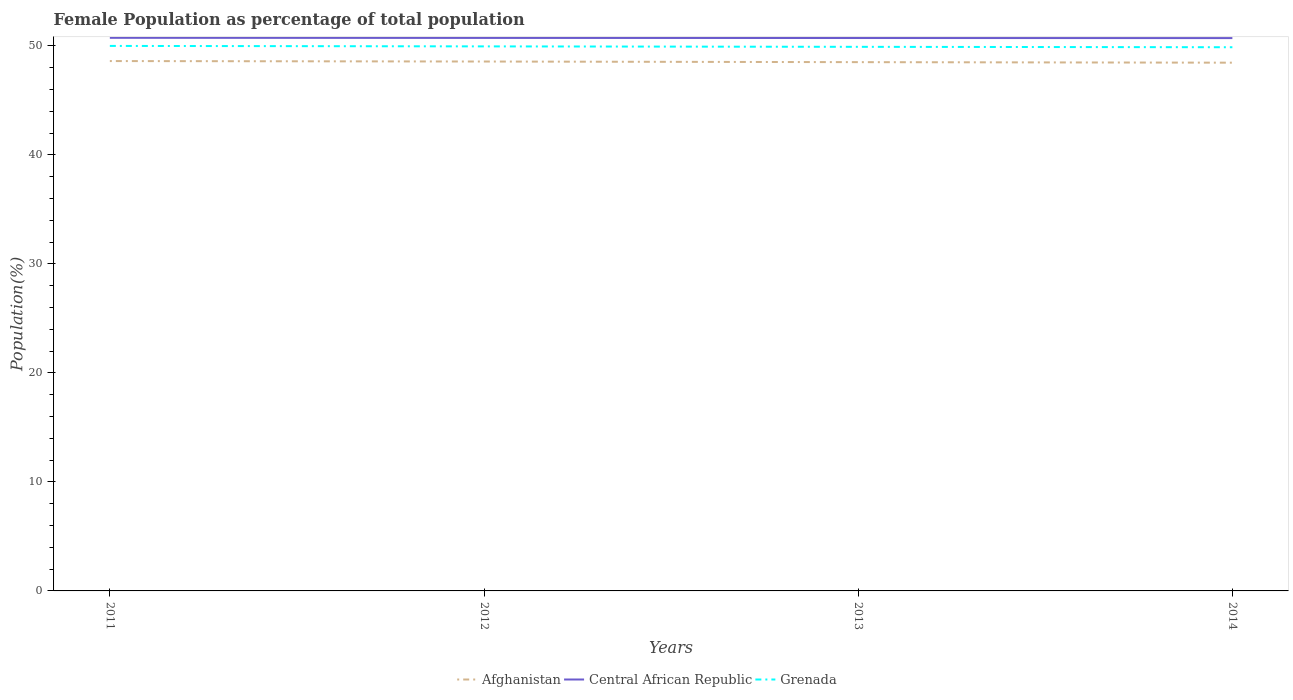How many different coloured lines are there?
Your response must be concise. 3. Does the line corresponding to Grenada intersect with the line corresponding to Afghanistan?
Provide a succinct answer. No. Is the number of lines equal to the number of legend labels?
Offer a very short reply. Yes. Across all years, what is the maximum female population in in Grenada?
Your answer should be compact. 49.87. In which year was the female population in in Central African Republic maximum?
Your answer should be very brief. 2014. What is the total female population in in Central African Republic in the graph?
Provide a short and direct response. 0.02. What is the difference between the highest and the second highest female population in in Central African Republic?
Offer a very short reply. 0.03. What is the difference between the highest and the lowest female population in in Afghanistan?
Offer a very short reply. 2. Does the graph contain any zero values?
Ensure brevity in your answer.  No. What is the title of the graph?
Offer a terse response. Female Population as percentage of total population. What is the label or title of the Y-axis?
Your answer should be very brief. Population(%). What is the Population(%) of Afghanistan in 2011?
Keep it short and to the point. 48.61. What is the Population(%) of Central African Republic in 2011?
Ensure brevity in your answer.  50.74. What is the Population(%) in Grenada in 2011?
Provide a succinct answer. 50. What is the Population(%) of Afghanistan in 2012?
Keep it short and to the point. 48.56. What is the Population(%) of Central African Republic in 2012?
Keep it short and to the point. 50.73. What is the Population(%) of Grenada in 2012?
Ensure brevity in your answer.  49.95. What is the Population(%) in Afghanistan in 2013?
Your answer should be compact. 48.51. What is the Population(%) in Central African Republic in 2013?
Ensure brevity in your answer.  50.72. What is the Population(%) in Grenada in 2013?
Your response must be concise. 49.91. What is the Population(%) of Afghanistan in 2014?
Provide a succinct answer. 48.46. What is the Population(%) in Central African Republic in 2014?
Offer a terse response. 50.71. What is the Population(%) of Grenada in 2014?
Your answer should be compact. 49.87. Across all years, what is the maximum Population(%) of Afghanistan?
Your answer should be very brief. 48.61. Across all years, what is the maximum Population(%) of Central African Republic?
Give a very brief answer. 50.74. Across all years, what is the maximum Population(%) in Grenada?
Your response must be concise. 50. Across all years, what is the minimum Population(%) in Afghanistan?
Provide a short and direct response. 48.46. Across all years, what is the minimum Population(%) of Central African Republic?
Make the answer very short. 50.71. Across all years, what is the minimum Population(%) in Grenada?
Keep it short and to the point. 49.87. What is the total Population(%) of Afghanistan in the graph?
Give a very brief answer. 194.14. What is the total Population(%) in Central African Republic in the graph?
Your response must be concise. 202.9. What is the total Population(%) in Grenada in the graph?
Offer a terse response. 199.73. What is the difference between the Population(%) of Afghanistan in 2011 and that in 2012?
Keep it short and to the point. 0.04. What is the difference between the Population(%) in Central African Republic in 2011 and that in 2012?
Your answer should be compact. 0.01. What is the difference between the Population(%) of Grenada in 2011 and that in 2012?
Keep it short and to the point. 0.04. What is the difference between the Population(%) of Afghanistan in 2011 and that in 2013?
Provide a short and direct response. 0.1. What is the difference between the Population(%) in Central African Republic in 2011 and that in 2013?
Provide a short and direct response. 0.02. What is the difference between the Population(%) in Grenada in 2011 and that in 2013?
Make the answer very short. 0.08. What is the difference between the Population(%) in Afghanistan in 2011 and that in 2014?
Your answer should be compact. 0.15. What is the difference between the Population(%) in Central African Republic in 2011 and that in 2014?
Offer a very short reply. 0.03. What is the difference between the Population(%) of Grenada in 2011 and that in 2014?
Ensure brevity in your answer.  0.12. What is the difference between the Population(%) of Afghanistan in 2012 and that in 2013?
Provide a short and direct response. 0.06. What is the difference between the Population(%) of Central African Republic in 2012 and that in 2013?
Offer a terse response. 0.01. What is the difference between the Population(%) in Grenada in 2012 and that in 2013?
Ensure brevity in your answer.  0.04. What is the difference between the Population(%) in Afghanistan in 2012 and that in 2014?
Make the answer very short. 0.11. What is the difference between the Population(%) of Central African Republic in 2012 and that in 2014?
Provide a short and direct response. 0.02. What is the difference between the Population(%) in Grenada in 2012 and that in 2014?
Offer a terse response. 0.08. What is the difference between the Population(%) in Afghanistan in 2013 and that in 2014?
Provide a short and direct response. 0.05. What is the difference between the Population(%) of Central African Republic in 2013 and that in 2014?
Give a very brief answer. 0.01. What is the difference between the Population(%) of Grenada in 2013 and that in 2014?
Ensure brevity in your answer.  0.04. What is the difference between the Population(%) of Afghanistan in 2011 and the Population(%) of Central African Republic in 2012?
Your answer should be very brief. -2.12. What is the difference between the Population(%) in Afghanistan in 2011 and the Population(%) in Grenada in 2012?
Your answer should be very brief. -1.35. What is the difference between the Population(%) in Central African Republic in 2011 and the Population(%) in Grenada in 2012?
Provide a succinct answer. 0.79. What is the difference between the Population(%) in Afghanistan in 2011 and the Population(%) in Central African Republic in 2013?
Offer a very short reply. -2.11. What is the difference between the Population(%) in Afghanistan in 2011 and the Population(%) in Grenada in 2013?
Your response must be concise. -1.31. What is the difference between the Population(%) of Central African Republic in 2011 and the Population(%) of Grenada in 2013?
Provide a succinct answer. 0.83. What is the difference between the Population(%) in Afghanistan in 2011 and the Population(%) in Central African Republic in 2014?
Give a very brief answer. -2.11. What is the difference between the Population(%) in Afghanistan in 2011 and the Population(%) in Grenada in 2014?
Give a very brief answer. -1.27. What is the difference between the Population(%) in Central African Republic in 2011 and the Population(%) in Grenada in 2014?
Offer a very short reply. 0.86. What is the difference between the Population(%) of Afghanistan in 2012 and the Population(%) of Central African Republic in 2013?
Give a very brief answer. -2.16. What is the difference between the Population(%) in Afghanistan in 2012 and the Population(%) in Grenada in 2013?
Give a very brief answer. -1.35. What is the difference between the Population(%) in Central African Republic in 2012 and the Population(%) in Grenada in 2013?
Provide a short and direct response. 0.82. What is the difference between the Population(%) in Afghanistan in 2012 and the Population(%) in Central African Republic in 2014?
Ensure brevity in your answer.  -2.15. What is the difference between the Population(%) in Afghanistan in 2012 and the Population(%) in Grenada in 2014?
Provide a short and direct response. -1.31. What is the difference between the Population(%) of Central African Republic in 2012 and the Population(%) of Grenada in 2014?
Offer a terse response. 0.85. What is the difference between the Population(%) in Afghanistan in 2013 and the Population(%) in Central African Republic in 2014?
Offer a terse response. -2.21. What is the difference between the Population(%) in Afghanistan in 2013 and the Population(%) in Grenada in 2014?
Offer a very short reply. -1.37. What is the difference between the Population(%) of Central African Republic in 2013 and the Population(%) of Grenada in 2014?
Offer a very short reply. 0.85. What is the average Population(%) of Afghanistan per year?
Keep it short and to the point. 48.53. What is the average Population(%) in Central African Republic per year?
Your response must be concise. 50.73. What is the average Population(%) of Grenada per year?
Your response must be concise. 49.93. In the year 2011, what is the difference between the Population(%) of Afghanistan and Population(%) of Central African Republic?
Provide a short and direct response. -2.13. In the year 2011, what is the difference between the Population(%) in Afghanistan and Population(%) in Grenada?
Your answer should be compact. -1.39. In the year 2011, what is the difference between the Population(%) of Central African Republic and Population(%) of Grenada?
Give a very brief answer. 0.74. In the year 2012, what is the difference between the Population(%) in Afghanistan and Population(%) in Central African Republic?
Your answer should be compact. -2.16. In the year 2012, what is the difference between the Population(%) of Afghanistan and Population(%) of Grenada?
Your answer should be very brief. -1.39. In the year 2012, what is the difference between the Population(%) of Central African Republic and Population(%) of Grenada?
Your answer should be very brief. 0.78. In the year 2013, what is the difference between the Population(%) of Afghanistan and Population(%) of Central African Republic?
Your answer should be very brief. -2.21. In the year 2013, what is the difference between the Population(%) of Afghanistan and Population(%) of Grenada?
Provide a succinct answer. -1.41. In the year 2013, what is the difference between the Population(%) of Central African Republic and Population(%) of Grenada?
Your response must be concise. 0.81. In the year 2014, what is the difference between the Population(%) of Afghanistan and Population(%) of Central African Republic?
Provide a succinct answer. -2.26. In the year 2014, what is the difference between the Population(%) of Afghanistan and Population(%) of Grenada?
Offer a terse response. -1.42. In the year 2014, what is the difference between the Population(%) in Central African Republic and Population(%) in Grenada?
Your response must be concise. 0.84. What is the ratio of the Population(%) in Central African Republic in 2011 to that in 2012?
Offer a very short reply. 1. What is the ratio of the Population(%) of Grenada in 2011 to that in 2012?
Provide a succinct answer. 1. What is the ratio of the Population(%) in Central African Republic in 2011 to that in 2013?
Keep it short and to the point. 1. What is the ratio of the Population(%) of Grenada in 2011 to that in 2013?
Offer a very short reply. 1. What is the ratio of the Population(%) in Afghanistan in 2011 to that in 2014?
Make the answer very short. 1. What is the ratio of the Population(%) of Central African Republic in 2011 to that in 2014?
Give a very brief answer. 1. What is the ratio of the Population(%) of Afghanistan in 2012 to that in 2013?
Offer a terse response. 1. What is the ratio of the Population(%) in Afghanistan in 2012 to that in 2014?
Ensure brevity in your answer.  1. What is the ratio of the Population(%) in Central African Republic in 2012 to that in 2014?
Your answer should be compact. 1. What is the ratio of the Population(%) of Afghanistan in 2013 to that in 2014?
Ensure brevity in your answer.  1. What is the ratio of the Population(%) in Grenada in 2013 to that in 2014?
Your response must be concise. 1. What is the difference between the highest and the second highest Population(%) of Afghanistan?
Provide a short and direct response. 0.04. What is the difference between the highest and the second highest Population(%) of Central African Republic?
Your response must be concise. 0.01. What is the difference between the highest and the second highest Population(%) in Grenada?
Offer a terse response. 0.04. What is the difference between the highest and the lowest Population(%) in Afghanistan?
Your answer should be compact. 0.15. What is the difference between the highest and the lowest Population(%) of Central African Republic?
Your response must be concise. 0.03. What is the difference between the highest and the lowest Population(%) in Grenada?
Provide a short and direct response. 0.12. 